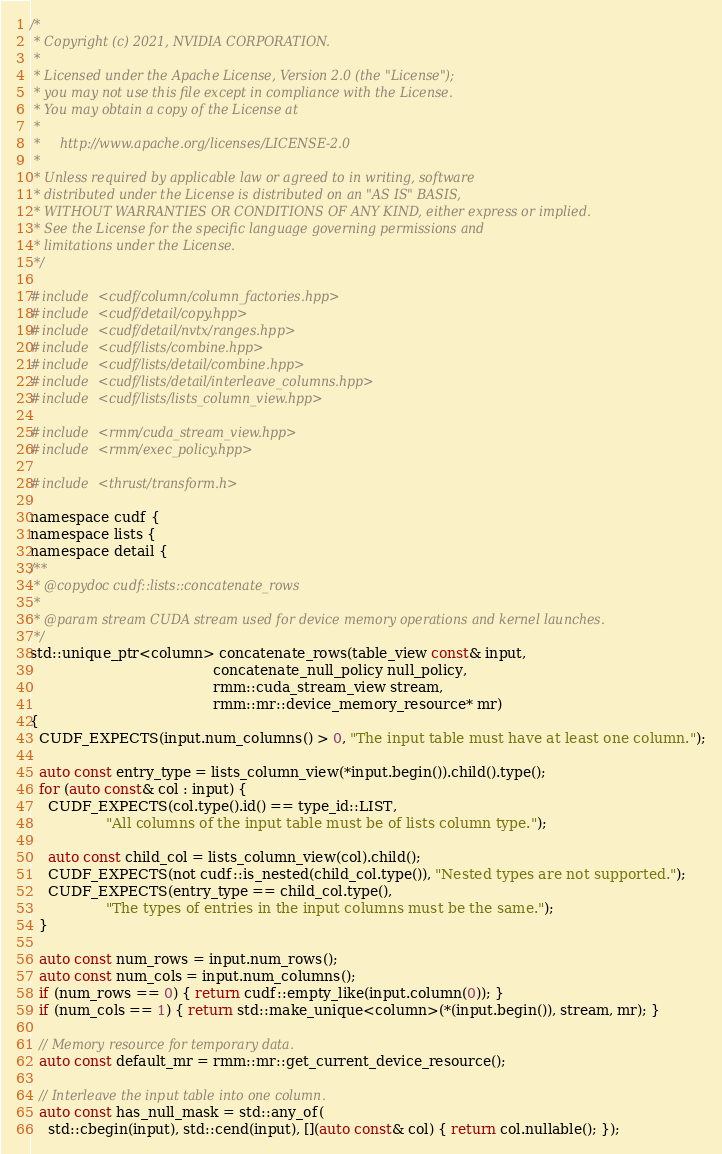Convert code to text. <code><loc_0><loc_0><loc_500><loc_500><_Cuda_>/*
 * Copyright (c) 2021, NVIDIA CORPORATION.
 *
 * Licensed under the Apache License, Version 2.0 (the "License");
 * you may not use this file except in compliance with the License.
 * You may obtain a copy of the License at
 *
 *     http://www.apache.org/licenses/LICENSE-2.0
 *
 * Unless required by applicable law or agreed to in writing, software
 * distributed under the License is distributed on an "AS IS" BASIS,
 * WITHOUT WARRANTIES OR CONDITIONS OF ANY KIND, either express or implied.
 * See the License for the specific language governing permissions and
 * limitations under the License.
 */

#include <cudf/column/column_factories.hpp>
#include <cudf/detail/copy.hpp>
#include <cudf/detail/nvtx/ranges.hpp>
#include <cudf/lists/combine.hpp>
#include <cudf/lists/detail/combine.hpp>
#include <cudf/lists/detail/interleave_columns.hpp>
#include <cudf/lists/lists_column_view.hpp>

#include <rmm/cuda_stream_view.hpp>
#include <rmm/exec_policy.hpp>

#include <thrust/transform.h>

namespace cudf {
namespace lists {
namespace detail {
/**
 * @copydoc cudf::lists::concatenate_rows
 *
 * @param stream CUDA stream used for device memory operations and kernel launches.
 */
std::unique_ptr<column> concatenate_rows(table_view const& input,
                                         concatenate_null_policy null_policy,
                                         rmm::cuda_stream_view stream,
                                         rmm::mr::device_memory_resource* mr)
{
  CUDF_EXPECTS(input.num_columns() > 0, "The input table must have at least one column.");

  auto const entry_type = lists_column_view(*input.begin()).child().type();
  for (auto const& col : input) {
    CUDF_EXPECTS(col.type().id() == type_id::LIST,
                 "All columns of the input table must be of lists column type.");

    auto const child_col = lists_column_view(col).child();
    CUDF_EXPECTS(not cudf::is_nested(child_col.type()), "Nested types are not supported.");
    CUDF_EXPECTS(entry_type == child_col.type(),
                 "The types of entries in the input columns must be the same.");
  }

  auto const num_rows = input.num_rows();
  auto const num_cols = input.num_columns();
  if (num_rows == 0) { return cudf::empty_like(input.column(0)); }
  if (num_cols == 1) { return std::make_unique<column>(*(input.begin()), stream, mr); }

  // Memory resource for temporary data.
  auto const default_mr = rmm::mr::get_current_device_resource();

  // Interleave the input table into one column.
  auto const has_null_mask = std::any_of(
    std::cbegin(input), std::cend(input), [](auto const& col) { return col.nullable(); });</code> 